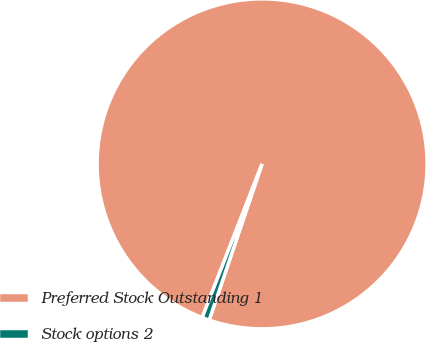Convert chart to OTSL. <chart><loc_0><loc_0><loc_500><loc_500><pie_chart><fcel>Preferred Stock Outstanding 1<fcel>Stock options 2<nl><fcel>99.28%<fcel>0.72%<nl></chart> 